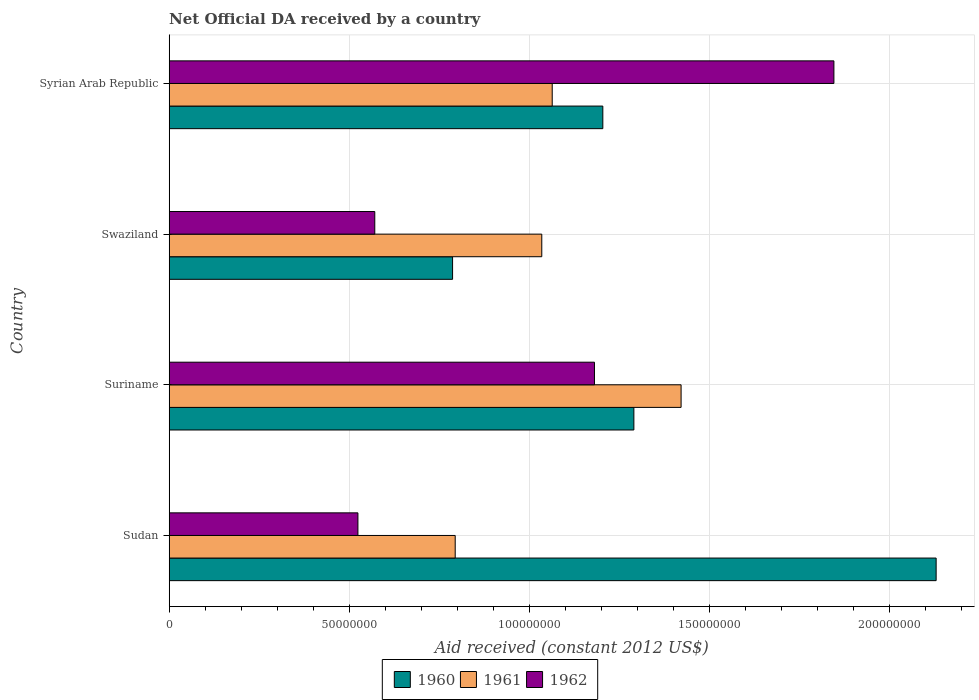How many groups of bars are there?
Provide a succinct answer. 4. Are the number of bars per tick equal to the number of legend labels?
Make the answer very short. Yes. Are the number of bars on each tick of the Y-axis equal?
Offer a very short reply. Yes. How many bars are there on the 3rd tick from the top?
Your answer should be very brief. 3. What is the label of the 1st group of bars from the top?
Give a very brief answer. Syrian Arab Republic. What is the net official development assistance aid received in 1961 in Swaziland?
Ensure brevity in your answer.  1.03e+08. Across all countries, what is the maximum net official development assistance aid received in 1961?
Ensure brevity in your answer.  1.42e+08. Across all countries, what is the minimum net official development assistance aid received in 1962?
Your answer should be very brief. 5.24e+07. In which country was the net official development assistance aid received in 1961 maximum?
Give a very brief answer. Suriname. In which country was the net official development assistance aid received in 1962 minimum?
Your answer should be very brief. Sudan. What is the total net official development assistance aid received in 1961 in the graph?
Make the answer very short. 4.31e+08. What is the difference between the net official development assistance aid received in 1960 in Sudan and that in Suriname?
Make the answer very short. 8.39e+07. What is the difference between the net official development assistance aid received in 1962 in Suriname and the net official development assistance aid received in 1961 in Swaziland?
Ensure brevity in your answer.  1.46e+07. What is the average net official development assistance aid received in 1962 per country?
Give a very brief answer. 1.03e+08. What is the difference between the net official development assistance aid received in 1962 and net official development assistance aid received in 1960 in Sudan?
Make the answer very short. -1.61e+08. What is the ratio of the net official development assistance aid received in 1962 in Sudan to that in Suriname?
Keep it short and to the point. 0.44. Is the net official development assistance aid received in 1962 in Swaziland less than that in Syrian Arab Republic?
Make the answer very short. Yes. What is the difference between the highest and the second highest net official development assistance aid received in 1962?
Provide a succinct answer. 6.65e+07. What is the difference between the highest and the lowest net official development assistance aid received in 1962?
Ensure brevity in your answer.  1.32e+08. In how many countries, is the net official development assistance aid received in 1961 greater than the average net official development assistance aid received in 1961 taken over all countries?
Offer a terse response. 1. Is it the case that in every country, the sum of the net official development assistance aid received in 1960 and net official development assistance aid received in 1961 is greater than the net official development assistance aid received in 1962?
Give a very brief answer. Yes. Where does the legend appear in the graph?
Ensure brevity in your answer.  Bottom center. How are the legend labels stacked?
Your answer should be compact. Horizontal. What is the title of the graph?
Ensure brevity in your answer.  Net Official DA received by a country. What is the label or title of the X-axis?
Ensure brevity in your answer.  Aid received (constant 2012 US$). What is the label or title of the Y-axis?
Your answer should be compact. Country. What is the Aid received (constant 2012 US$) in 1960 in Sudan?
Your answer should be compact. 2.13e+08. What is the Aid received (constant 2012 US$) of 1961 in Sudan?
Ensure brevity in your answer.  7.94e+07. What is the Aid received (constant 2012 US$) of 1962 in Sudan?
Offer a terse response. 5.24e+07. What is the Aid received (constant 2012 US$) of 1960 in Suriname?
Give a very brief answer. 1.29e+08. What is the Aid received (constant 2012 US$) in 1961 in Suriname?
Your response must be concise. 1.42e+08. What is the Aid received (constant 2012 US$) in 1962 in Suriname?
Give a very brief answer. 1.18e+08. What is the Aid received (constant 2012 US$) in 1960 in Swaziland?
Your answer should be very brief. 7.87e+07. What is the Aid received (constant 2012 US$) of 1961 in Swaziland?
Your answer should be very brief. 1.03e+08. What is the Aid received (constant 2012 US$) in 1962 in Swaziland?
Offer a very short reply. 5.71e+07. What is the Aid received (constant 2012 US$) in 1960 in Syrian Arab Republic?
Give a very brief answer. 1.20e+08. What is the Aid received (constant 2012 US$) of 1961 in Syrian Arab Republic?
Offer a terse response. 1.06e+08. What is the Aid received (constant 2012 US$) of 1962 in Syrian Arab Republic?
Your answer should be compact. 1.85e+08. Across all countries, what is the maximum Aid received (constant 2012 US$) in 1960?
Ensure brevity in your answer.  2.13e+08. Across all countries, what is the maximum Aid received (constant 2012 US$) in 1961?
Make the answer very short. 1.42e+08. Across all countries, what is the maximum Aid received (constant 2012 US$) in 1962?
Ensure brevity in your answer.  1.85e+08. Across all countries, what is the minimum Aid received (constant 2012 US$) in 1960?
Ensure brevity in your answer.  7.87e+07. Across all countries, what is the minimum Aid received (constant 2012 US$) in 1961?
Keep it short and to the point. 7.94e+07. Across all countries, what is the minimum Aid received (constant 2012 US$) in 1962?
Make the answer very short. 5.24e+07. What is the total Aid received (constant 2012 US$) of 1960 in the graph?
Make the answer very short. 5.41e+08. What is the total Aid received (constant 2012 US$) in 1961 in the graph?
Offer a very short reply. 4.31e+08. What is the total Aid received (constant 2012 US$) in 1962 in the graph?
Give a very brief answer. 4.12e+08. What is the difference between the Aid received (constant 2012 US$) in 1960 in Sudan and that in Suriname?
Provide a succinct answer. 8.39e+07. What is the difference between the Aid received (constant 2012 US$) of 1961 in Sudan and that in Suriname?
Offer a terse response. -6.27e+07. What is the difference between the Aid received (constant 2012 US$) of 1962 in Sudan and that in Suriname?
Give a very brief answer. -6.57e+07. What is the difference between the Aid received (constant 2012 US$) in 1960 in Sudan and that in Swaziland?
Give a very brief answer. 1.34e+08. What is the difference between the Aid received (constant 2012 US$) in 1961 in Sudan and that in Swaziland?
Your response must be concise. -2.40e+07. What is the difference between the Aid received (constant 2012 US$) in 1962 in Sudan and that in Swaziland?
Your answer should be very brief. -4.68e+06. What is the difference between the Aid received (constant 2012 US$) of 1960 in Sudan and that in Syrian Arab Republic?
Provide a succinct answer. 9.26e+07. What is the difference between the Aid received (constant 2012 US$) of 1961 in Sudan and that in Syrian Arab Republic?
Keep it short and to the point. -2.69e+07. What is the difference between the Aid received (constant 2012 US$) in 1962 in Sudan and that in Syrian Arab Republic?
Ensure brevity in your answer.  -1.32e+08. What is the difference between the Aid received (constant 2012 US$) in 1960 in Suriname and that in Swaziland?
Give a very brief answer. 5.03e+07. What is the difference between the Aid received (constant 2012 US$) of 1961 in Suriname and that in Swaziland?
Provide a succinct answer. 3.87e+07. What is the difference between the Aid received (constant 2012 US$) in 1962 in Suriname and that in Swaziland?
Your response must be concise. 6.10e+07. What is the difference between the Aid received (constant 2012 US$) of 1960 in Suriname and that in Syrian Arab Republic?
Give a very brief answer. 8.62e+06. What is the difference between the Aid received (constant 2012 US$) in 1961 in Suriname and that in Syrian Arab Republic?
Provide a succinct answer. 3.58e+07. What is the difference between the Aid received (constant 2012 US$) in 1962 in Suriname and that in Syrian Arab Republic?
Your response must be concise. -6.65e+07. What is the difference between the Aid received (constant 2012 US$) of 1960 in Swaziland and that in Syrian Arab Republic?
Provide a succinct answer. -4.17e+07. What is the difference between the Aid received (constant 2012 US$) of 1961 in Swaziland and that in Syrian Arab Republic?
Make the answer very short. -2.90e+06. What is the difference between the Aid received (constant 2012 US$) in 1962 in Swaziland and that in Syrian Arab Republic?
Provide a short and direct response. -1.27e+08. What is the difference between the Aid received (constant 2012 US$) of 1960 in Sudan and the Aid received (constant 2012 US$) of 1961 in Suriname?
Keep it short and to the point. 7.08e+07. What is the difference between the Aid received (constant 2012 US$) of 1960 in Sudan and the Aid received (constant 2012 US$) of 1962 in Suriname?
Keep it short and to the point. 9.49e+07. What is the difference between the Aid received (constant 2012 US$) in 1961 in Sudan and the Aid received (constant 2012 US$) in 1962 in Suriname?
Your answer should be compact. -3.87e+07. What is the difference between the Aid received (constant 2012 US$) of 1960 in Sudan and the Aid received (constant 2012 US$) of 1961 in Swaziland?
Make the answer very short. 1.10e+08. What is the difference between the Aid received (constant 2012 US$) of 1960 in Sudan and the Aid received (constant 2012 US$) of 1962 in Swaziland?
Keep it short and to the point. 1.56e+08. What is the difference between the Aid received (constant 2012 US$) in 1961 in Sudan and the Aid received (constant 2012 US$) in 1962 in Swaziland?
Your answer should be very brief. 2.23e+07. What is the difference between the Aid received (constant 2012 US$) in 1960 in Sudan and the Aid received (constant 2012 US$) in 1961 in Syrian Arab Republic?
Provide a short and direct response. 1.07e+08. What is the difference between the Aid received (constant 2012 US$) in 1960 in Sudan and the Aid received (constant 2012 US$) in 1962 in Syrian Arab Republic?
Keep it short and to the point. 2.84e+07. What is the difference between the Aid received (constant 2012 US$) of 1961 in Sudan and the Aid received (constant 2012 US$) of 1962 in Syrian Arab Republic?
Your answer should be very brief. -1.05e+08. What is the difference between the Aid received (constant 2012 US$) in 1960 in Suriname and the Aid received (constant 2012 US$) in 1961 in Swaziland?
Give a very brief answer. 2.56e+07. What is the difference between the Aid received (constant 2012 US$) of 1960 in Suriname and the Aid received (constant 2012 US$) of 1962 in Swaziland?
Provide a short and direct response. 7.19e+07. What is the difference between the Aid received (constant 2012 US$) in 1961 in Suriname and the Aid received (constant 2012 US$) in 1962 in Swaziland?
Make the answer very short. 8.50e+07. What is the difference between the Aid received (constant 2012 US$) of 1960 in Suriname and the Aid received (constant 2012 US$) of 1961 in Syrian Arab Republic?
Make the answer very short. 2.27e+07. What is the difference between the Aid received (constant 2012 US$) of 1960 in Suriname and the Aid received (constant 2012 US$) of 1962 in Syrian Arab Republic?
Offer a very short reply. -5.55e+07. What is the difference between the Aid received (constant 2012 US$) in 1961 in Suriname and the Aid received (constant 2012 US$) in 1962 in Syrian Arab Republic?
Your answer should be compact. -4.24e+07. What is the difference between the Aid received (constant 2012 US$) of 1960 in Swaziland and the Aid received (constant 2012 US$) of 1961 in Syrian Arab Republic?
Offer a very short reply. -2.77e+07. What is the difference between the Aid received (constant 2012 US$) of 1960 in Swaziland and the Aid received (constant 2012 US$) of 1962 in Syrian Arab Republic?
Offer a terse response. -1.06e+08. What is the difference between the Aid received (constant 2012 US$) in 1961 in Swaziland and the Aid received (constant 2012 US$) in 1962 in Syrian Arab Republic?
Make the answer very short. -8.11e+07. What is the average Aid received (constant 2012 US$) of 1960 per country?
Provide a short and direct response. 1.35e+08. What is the average Aid received (constant 2012 US$) of 1961 per country?
Provide a short and direct response. 1.08e+08. What is the average Aid received (constant 2012 US$) in 1962 per country?
Provide a short and direct response. 1.03e+08. What is the difference between the Aid received (constant 2012 US$) in 1960 and Aid received (constant 2012 US$) in 1961 in Sudan?
Your answer should be very brief. 1.34e+08. What is the difference between the Aid received (constant 2012 US$) in 1960 and Aid received (constant 2012 US$) in 1962 in Sudan?
Offer a terse response. 1.61e+08. What is the difference between the Aid received (constant 2012 US$) in 1961 and Aid received (constant 2012 US$) in 1962 in Sudan?
Your answer should be very brief. 2.70e+07. What is the difference between the Aid received (constant 2012 US$) in 1960 and Aid received (constant 2012 US$) in 1961 in Suriname?
Offer a terse response. -1.31e+07. What is the difference between the Aid received (constant 2012 US$) of 1960 and Aid received (constant 2012 US$) of 1962 in Suriname?
Give a very brief answer. 1.09e+07. What is the difference between the Aid received (constant 2012 US$) in 1961 and Aid received (constant 2012 US$) in 1962 in Suriname?
Offer a very short reply. 2.40e+07. What is the difference between the Aid received (constant 2012 US$) in 1960 and Aid received (constant 2012 US$) in 1961 in Swaziland?
Ensure brevity in your answer.  -2.48e+07. What is the difference between the Aid received (constant 2012 US$) in 1960 and Aid received (constant 2012 US$) in 1962 in Swaziland?
Your response must be concise. 2.16e+07. What is the difference between the Aid received (constant 2012 US$) in 1961 and Aid received (constant 2012 US$) in 1962 in Swaziland?
Your answer should be compact. 4.64e+07. What is the difference between the Aid received (constant 2012 US$) of 1960 and Aid received (constant 2012 US$) of 1961 in Syrian Arab Republic?
Your answer should be very brief. 1.40e+07. What is the difference between the Aid received (constant 2012 US$) of 1960 and Aid received (constant 2012 US$) of 1962 in Syrian Arab Republic?
Provide a short and direct response. -6.42e+07. What is the difference between the Aid received (constant 2012 US$) of 1961 and Aid received (constant 2012 US$) of 1962 in Syrian Arab Republic?
Provide a short and direct response. -7.82e+07. What is the ratio of the Aid received (constant 2012 US$) of 1960 in Sudan to that in Suriname?
Make the answer very short. 1.65. What is the ratio of the Aid received (constant 2012 US$) of 1961 in Sudan to that in Suriname?
Give a very brief answer. 0.56. What is the ratio of the Aid received (constant 2012 US$) of 1962 in Sudan to that in Suriname?
Provide a short and direct response. 0.44. What is the ratio of the Aid received (constant 2012 US$) of 1960 in Sudan to that in Swaziland?
Offer a terse response. 2.71. What is the ratio of the Aid received (constant 2012 US$) in 1961 in Sudan to that in Swaziland?
Provide a succinct answer. 0.77. What is the ratio of the Aid received (constant 2012 US$) of 1962 in Sudan to that in Swaziland?
Your answer should be very brief. 0.92. What is the ratio of the Aid received (constant 2012 US$) in 1960 in Sudan to that in Syrian Arab Republic?
Your answer should be very brief. 1.77. What is the ratio of the Aid received (constant 2012 US$) in 1961 in Sudan to that in Syrian Arab Republic?
Ensure brevity in your answer.  0.75. What is the ratio of the Aid received (constant 2012 US$) of 1962 in Sudan to that in Syrian Arab Republic?
Keep it short and to the point. 0.28. What is the ratio of the Aid received (constant 2012 US$) of 1960 in Suriname to that in Swaziland?
Your answer should be very brief. 1.64. What is the ratio of the Aid received (constant 2012 US$) in 1961 in Suriname to that in Swaziland?
Your response must be concise. 1.37. What is the ratio of the Aid received (constant 2012 US$) of 1962 in Suriname to that in Swaziland?
Provide a short and direct response. 2.07. What is the ratio of the Aid received (constant 2012 US$) in 1960 in Suriname to that in Syrian Arab Republic?
Your answer should be compact. 1.07. What is the ratio of the Aid received (constant 2012 US$) of 1961 in Suriname to that in Syrian Arab Republic?
Your response must be concise. 1.34. What is the ratio of the Aid received (constant 2012 US$) of 1962 in Suriname to that in Syrian Arab Republic?
Ensure brevity in your answer.  0.64. What is the ratio of the Aid received (constant 2012 US$) of 1960 in Swaziland to that in Syrian Arab Republic?
Keep it short and to the point. 0.65. What is the ratio of the Aid received (constant 2012 US$) in 1961 in Swaziland to that in Syrian Arab Republic?
Provide a short and direct response. 0.97. What is the ratio of the Aid received (constant 2012 US$) in 1962 in Swaziland to that in Syrian Arab Republic?
Make the answer very short. 0.31. What is the difference between the highest and the second highest Aid received (constant 2012 US$) of 1960?
Your answer should be compact. 8.39e+07. What is the difference between the highest and the second highest Aid received (constant 2012 US$) of 1961?
Provide a succinct answer. 3.58e+07. What is the difference between the highest and the second highest Aid received (constant 2012 US$) of 1962?
Your answer should be compact. 6.65e+07. What is the difference between the highest and the lowest Aid received (constant 2012 US$) of 1960?
Keep it short and to the point. 1.34e+08. What is the difference between the highest and the lowest Aid received (constant 2012 US$) in 1961?
Give a very brief answer. 6.27e+07. What is the difference between the highest and the lowest Aid received (constant 2012 US$) of 1962?
Your answer should be compact. 1.32e+08. 